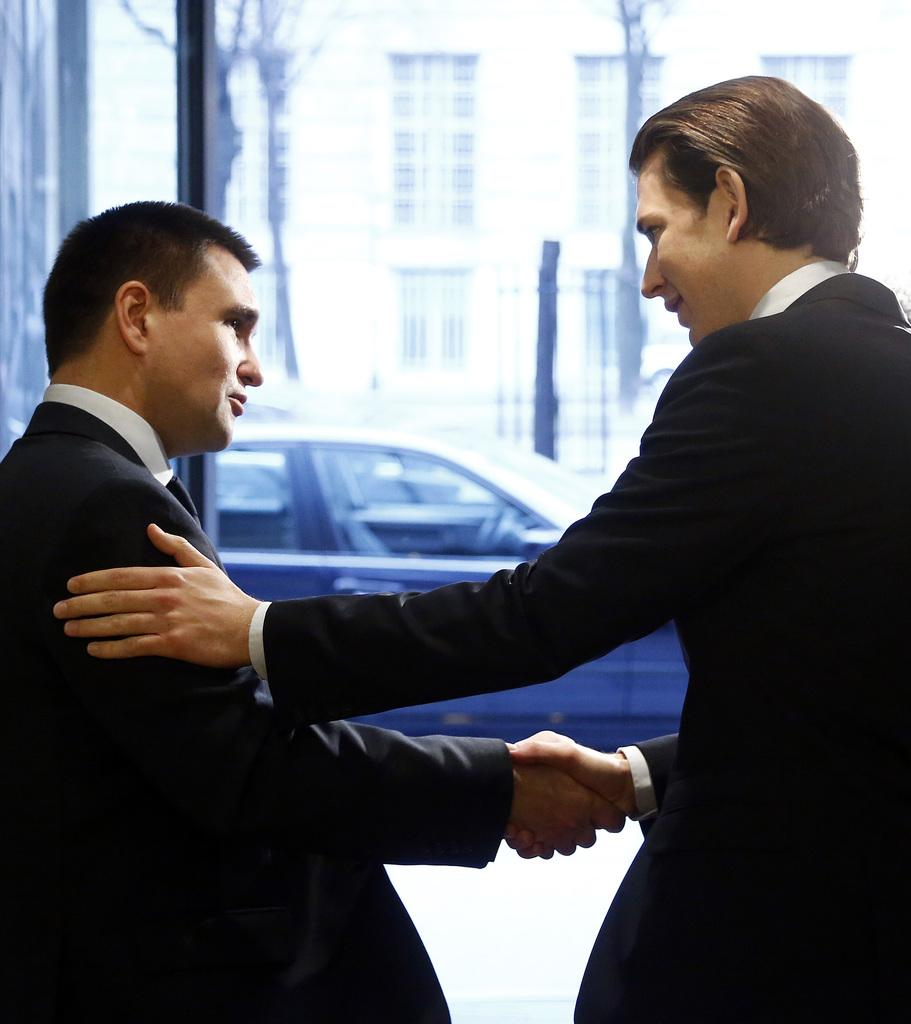How many people are in the image? There are two persons in the image. What are the two persons doing? The two persons are shaking hands. What can be seen in the background of the image? There is a vehicle, at least one building, and poles in the background of the image. What type of cabbage is growing on the poles in the background? There is no cabbage present in the image, and the poles do not have any plants growing on them. 